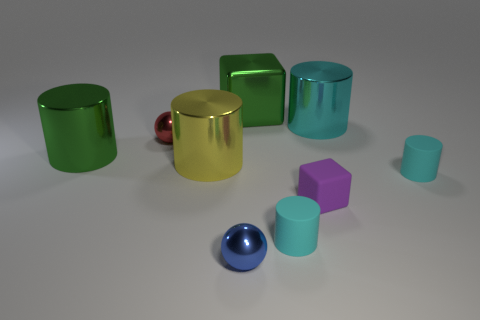Subtract all big yellow cylinders. How many cylinders are left? 4 Subtract all big cyan matte blocks. Subtract all cyan matte things. How many objects are left? 7 Add 7 tiny purple rubber things. How many tiny purple rubber things are left? 8 Add 6 tiny rubber things. How many tiny rubber things exist? 9 Subtract all red balls. How many balls are left? 1 Subtract 0 yellow spheres. How many objects are left? 9 Subtract all balls. How many objects are left? 7 Subtract 2 spheres. How many spheres are left? 0 Subtract all yellow spheres. Subtract all cyan cubes. How many spheres are left? 2 Subtract all red cylinders. How many gray spheres are left? 0 